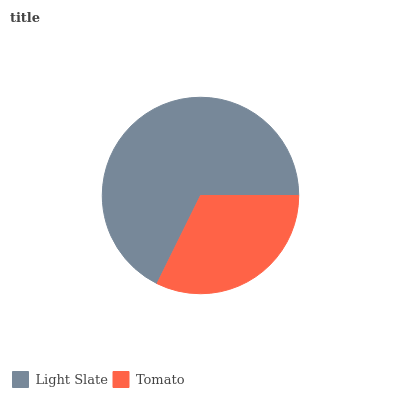Is Tomato the minimum?
Answer yes or no. Yes. Is Light Slate the maximum?
Answer yes or no. Yes. Is Tomato the maximum?
Answer yes or no. No. Is Light Slate greater than Tomato?
Answer yes or no. Yes. Is Tomato less than Light Slate?
Answer yes or no. Yes. Is Tomato greater than Light Slate?
Answer yes or no. No. Is Light Slate less than Tomato?
Answer yes or no. No. Is Light Slate the high median?
Answer yes or no. Yes. Is Tomato the low median?
Answer yes or no. Yes. Is Tomato the high median?
Answer yes or no. No. Is Light Slate the low median?
Answer yes or no. No. 